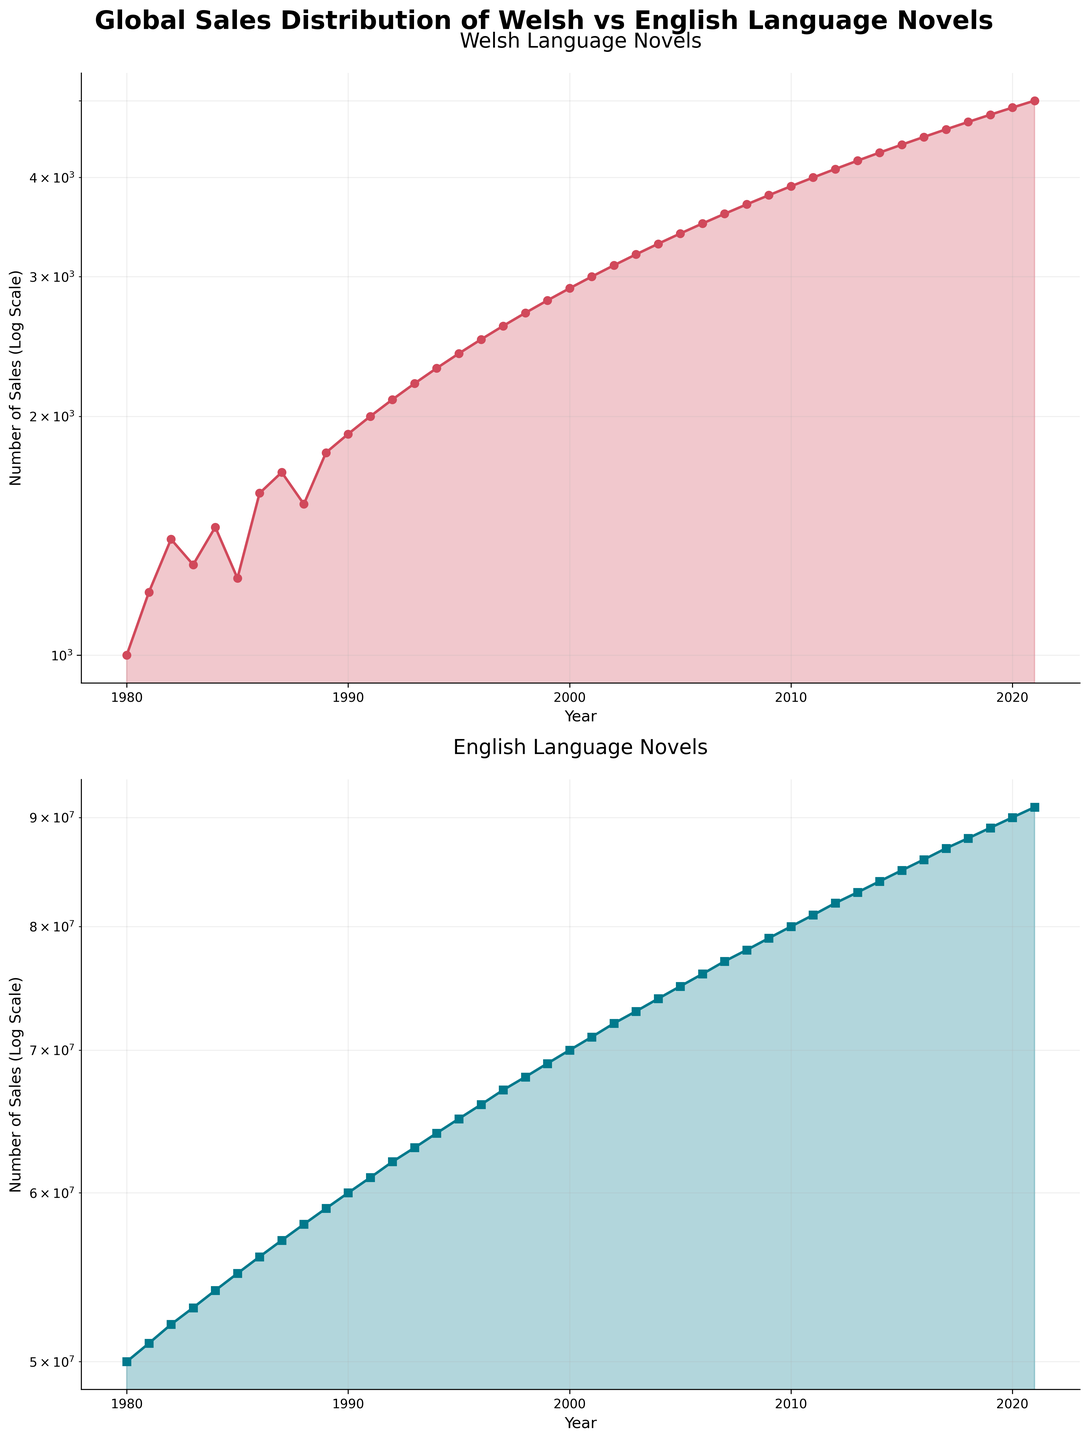How many data points are there for Welsh language novels? The plot shows a continuous line with markers for each year from 1980 to 2021. To find the number of data points, count the markers.
Answer: 42 How do the overall sales trends of Welsh and English language novels compare? Both plots use a logarithmic scale. Comparing the trends visually, sales for both languages increase over the years, but English language novel sales are much higher than Welsh language novel sales.
Answer: Both trends increase, but English sales are much higher In which year did Welsh language novel sales first reach 3000? Look at the plot for Welsh language novels and identify the year where the line first touches the 3000 sales mark.
Answer: 2001 What is the sales difference between Welsh and English language novels in 1985? Identify the sales for both Welsh and English novels at 1985 from the respective plots, then subtract the sales of Welsh from English.
Answer: 54,987,750 By how much did the sales of Welsh language novels increase from 1990 to 2000? Look at the Welsh plot and find the sales values for 1990 and 2000. Then subtract the 1990 sales from the 2000 sales to find the increase.
Answer: 1000 sales How does the growth rate of Welsh language novels from 1980 to 1990 compare to the growth rate from 2010 to 2020? Calculate the growth rate for Welsh novels for each period: (1990 sales - 1980 sales) and (2020 sales - 2010 sales). Then compare these growth values.
Answer: 900 (1980-1990) vs 1000 (2010-2020) What color line represents the sales of English language novels? Look at the plot where the sales of English language novels are depicted. Identify the color of the line representing sales.
Answer: Blue Which subplot shows a higher maximum sales value? Compare the maximum values in each subplot; the subplot with the highest value represents the higher maximum sales.
Answer: English language novels subplot 